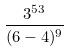<formula> <loc_0><loc_0><loc_500><loc_500>\frac { 3 ^ { 5 3 } } { ( 6 - 4 ) ^ { 9 } }</formula> 